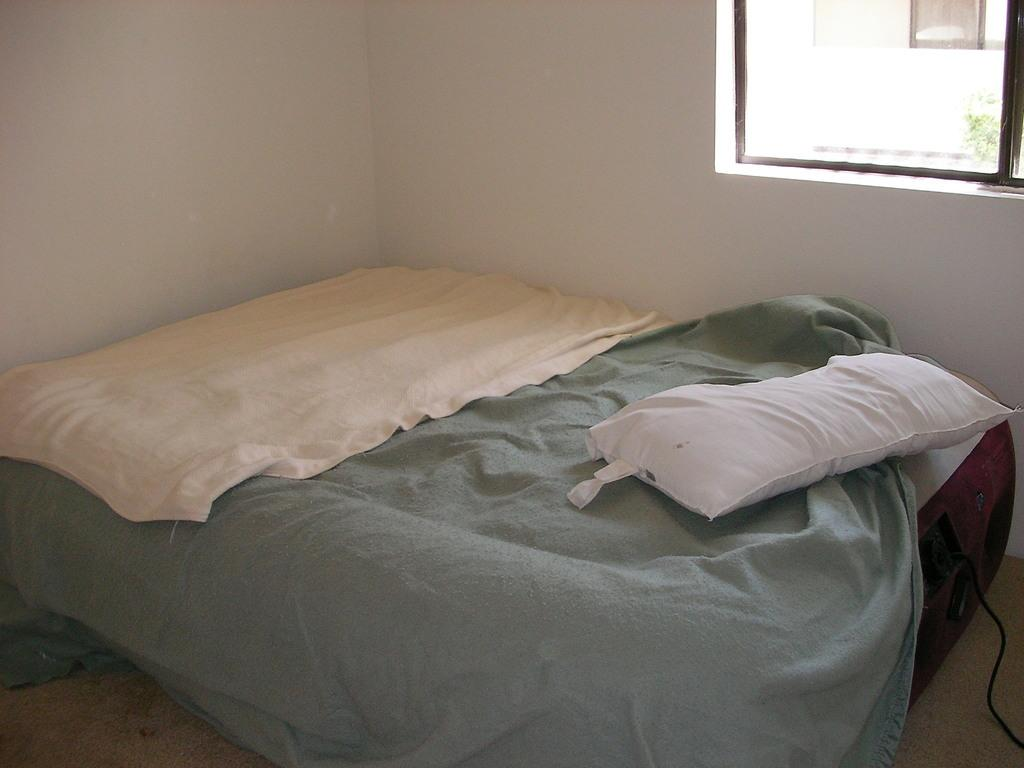What is the main object in the center of the image? There is a bed in the center of the image. What can be seen in the background of the image? There is a wall and a window in the background of the image. What is covering the floor in the image? There is a carpet at the bottom of the image. Is there a bowl of rice on the bed in the image? There is no bowl of rice present in the image. 